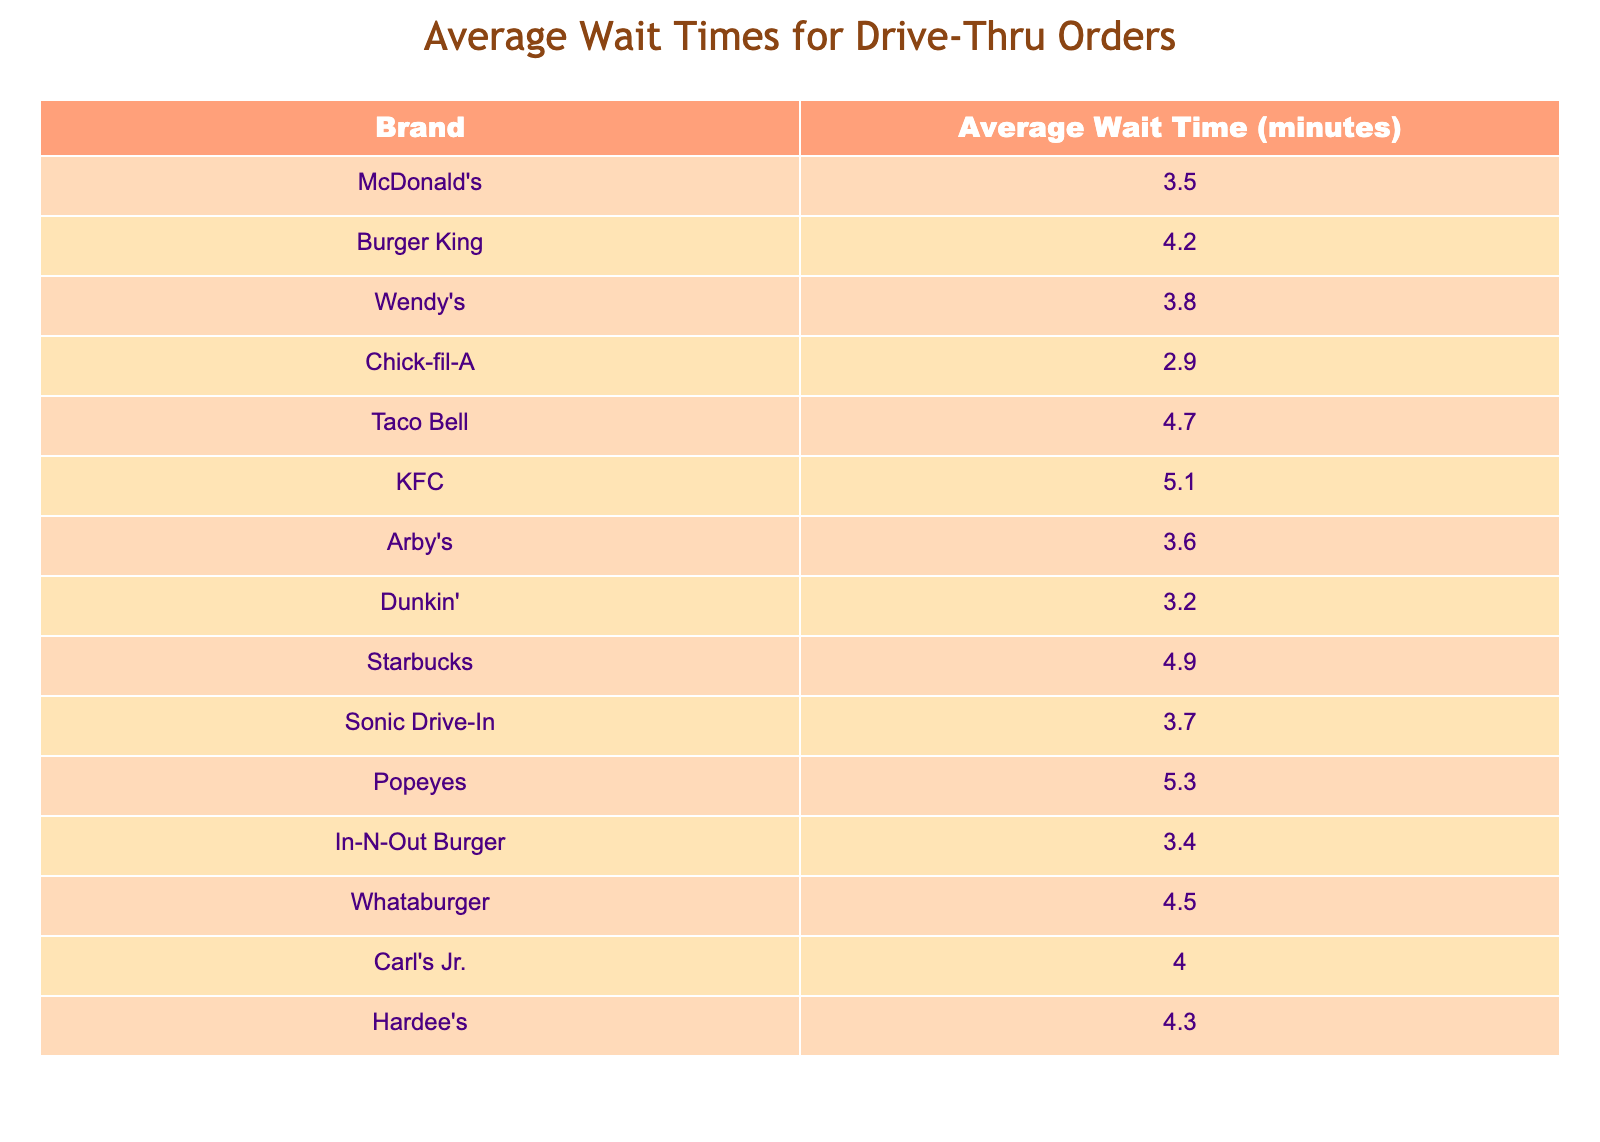What is the average wait time for Chick-fil-A? According to the table, Chick-fil-A has an average wait time of 2.9 minutes.
Answer: 2.9 Which fast food brand has the longest average wait time? The table shows that Popeyes has the longest average wait time at 5.3 minutes.
Answer: 5.3 What is the average wait time for Taco Bell and KFC combined? Taco Bell has an average wait time of 4.7 minutes, and KFC has 5.1 minutes. Adding these gives 4.7 + 5.1 = 9.8 minutes. Since there are two brands, the average is 9.8 / 2 = 4.9 minutes.
Answer: 4.9 Is the average wait time for Dunkin' greater than 3 minutes? The table lists Dunkin' with an average wait time of 3.2 minutes, which is greater than 3 minutes.
Answer: Yes How much longer, on average, is the wait time at KFC compared to Chick-fil-A? KFC has an average wait time of 5.1 minutes while Chick-fil-A has 2.9 minutes. The difference is calculated as 5.1 - 2.9 = 2.2 minutes.
Answer: 2.2 What is the average wait time for the following brands: McDonald's, Wendy's, and Sonic Drive-In? McDonald's has 3.5 minutes, Wendy's has 3.8 minutes, and Sonic Drive-In has 3.7 minutes. Their total wait time is 3.5 + 3.8 + 3.7 = 11.0 minutes. The average is 11.0 / 3 = 3.67 minutes.
Answer: 3.67 Which brands have an average wait time of less than 4 minutes? From the table, the brands with average wait times of less than 4 minutes are Chick-fil-A (2.9 minutes), Dunkin' (3.2 minutes), In-N-Out Burger (3.4 minutes), McDonald's (3.5 minutes), Wendy's (3.8 minutes), and Sonic Drive-In (3.7 minutes).
Answer: Chick-fil-A, Dunkin', In-N-Out Burger, McDonald's, Wendy's, Sonic Drive-In Is Wendy's wait time less than Burger King's? Wendy's has an average wait time of 3.8 minutes, while Burger King has 4.2 minutes; therefore, Wendy's wait time is less.
Answer: Yes 